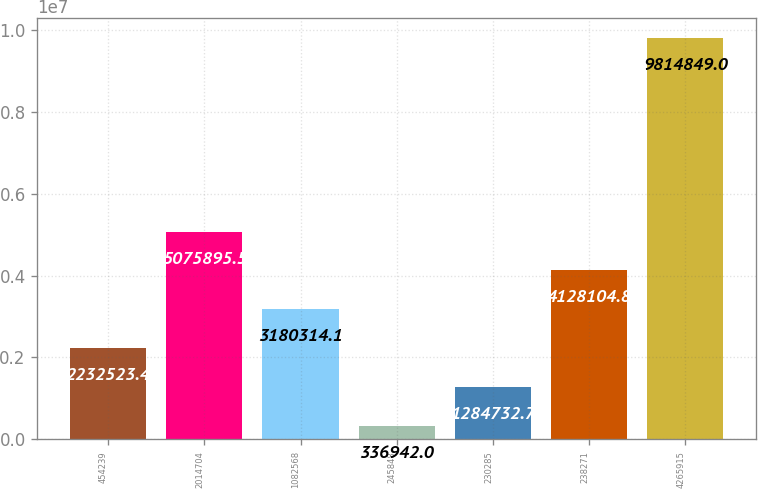Convert chart to OTSL. <chart><loc_0><loc_0><loc_500><loc_500><bar_chart><fcel>454239<fcel>2014704<fcel>1082568<fcel>245848<fcel>230285<fcel>238271<fcel>4265915<nl><fcel>2.23252e+06<fcel>5.0759e+06<fcel>3.18031e+06<fcel>336942<fcel>1.28473e+06<fcel>4.1281e+06<fcel>9.81485e+06<nl></chart> 